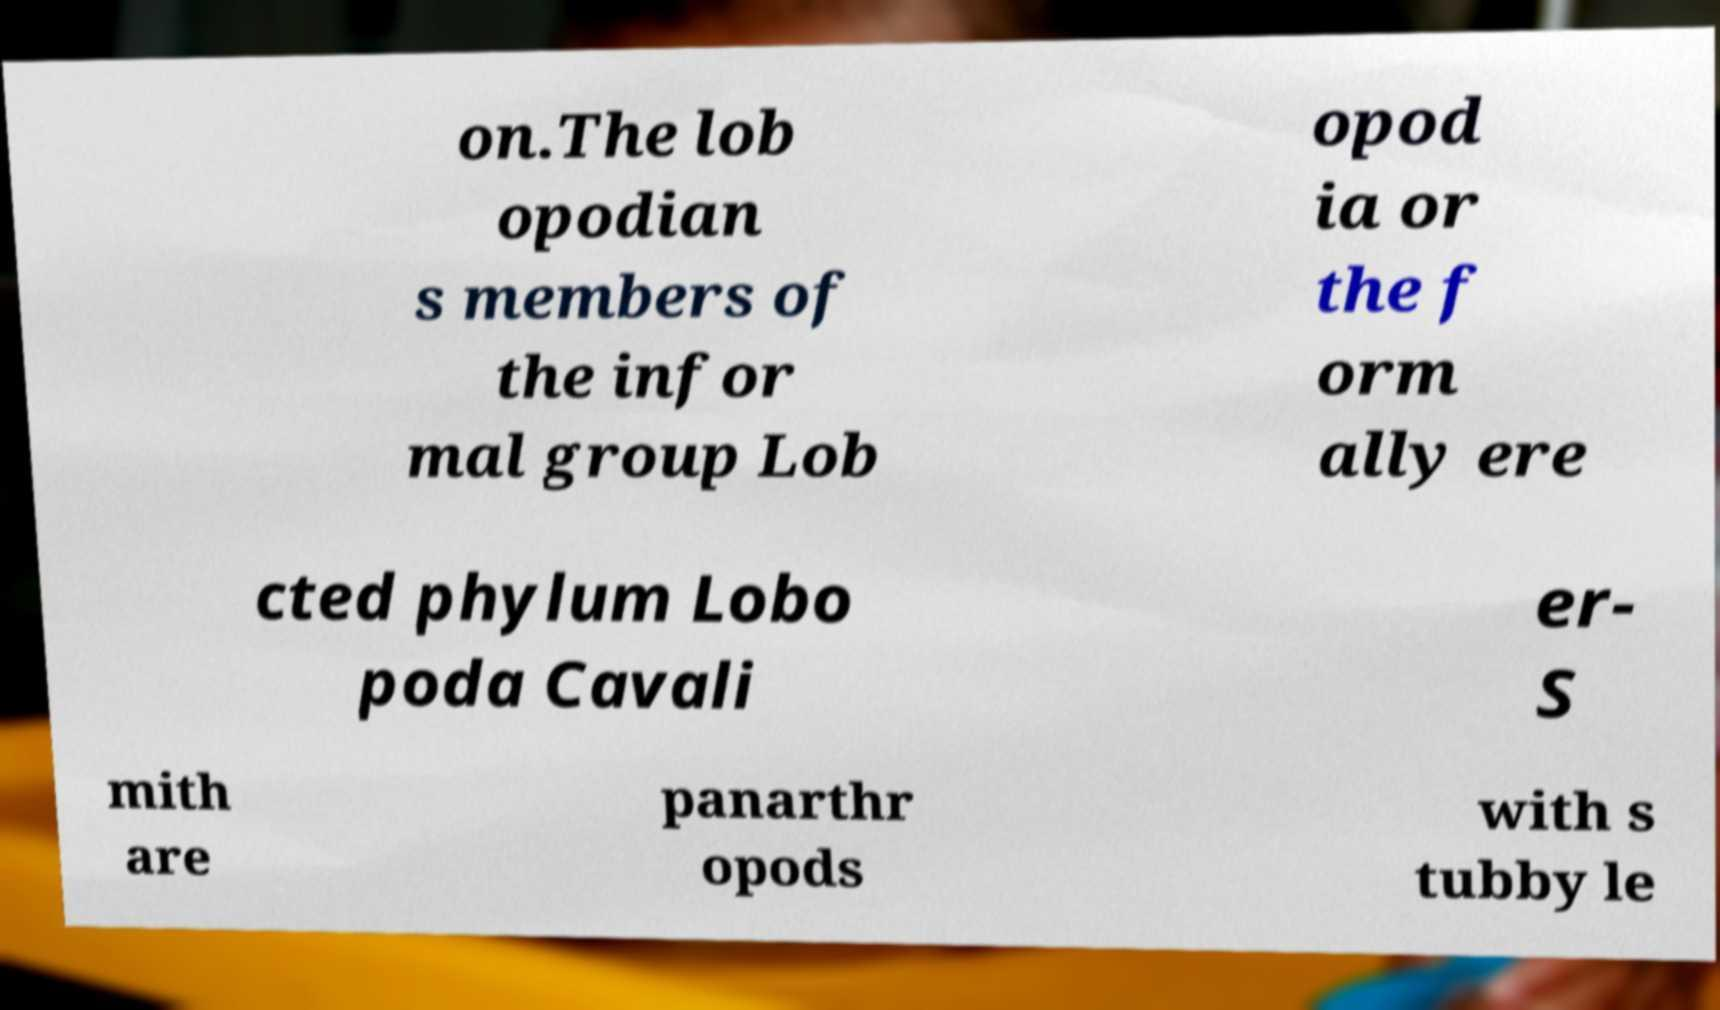Please read and relay the text visible in this image. What does it say? on.The lob opodian s members of the infor mal group Lob opod ia or the f orm ally ere cted phylum Lobo poda Cavali er- S mith are panarthr opods with s tubby le 